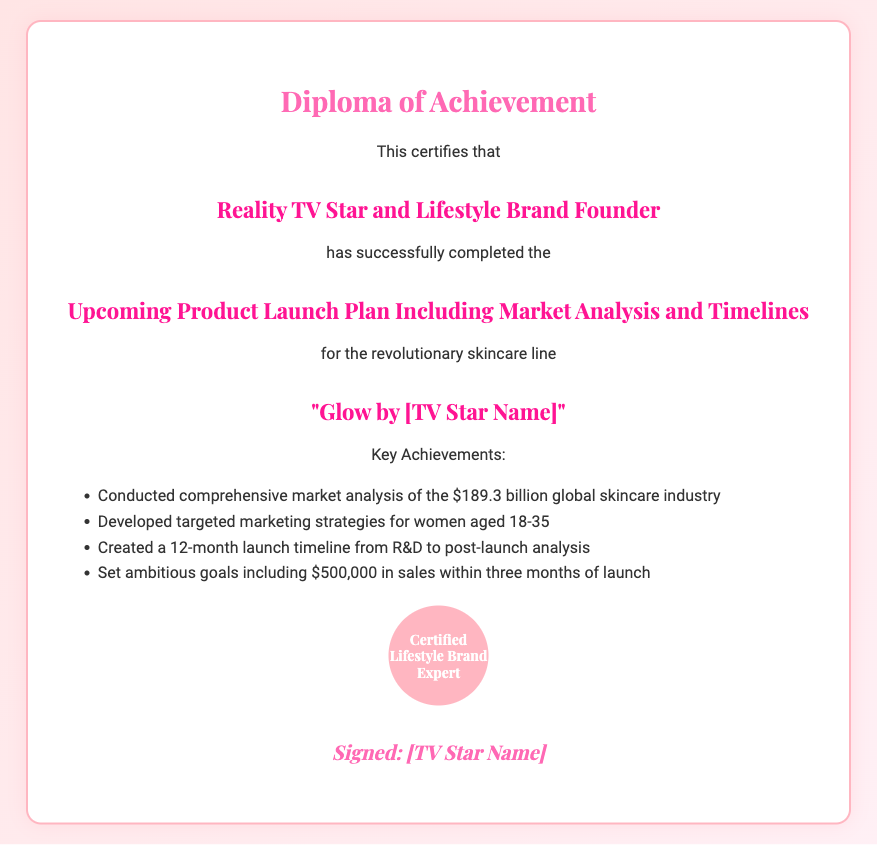What is the title of the diploma? The title of the diploma is stated in bold at the top of the document.
Answer: Upcoming Product Launch Plan Including Market Analysis and Timelines Who is the subject of the diploma? The subject of the diploma is mentioned right after the certification statement.
Answer: Reality TV Star and Lifestyle Brand Founder What is the skincare line being launched? The skincare line is highlighted in the section discussing the achievements of the diploma.
Answer: Glow by [TV Star Name] What is the targeted age group for marketing strategies? The age group is specified in the list of key achievements.
Answer: Women aged 18-35 What is the sales goal within three months of launch? The sales goal is mentioned as part of the ambitious goals set for the product launch.
Answer: $500,000 How long is the launch timeline provided? The length of the launch timeline is stated in the key achievements section.
Answer: 12 months What is the total value of the global skincare industry mentioned? The total value is included in the market analysis section of the diploma.
Answer: $189.3 billion What does the seal on the diploma state? The seal provides a certification statement unique to the diploma.
Answer: Certified Lifestyle Brand Expert Who signed the diploma? The signature section of the document indicates the signer.
Answer: [TV Star Name] 